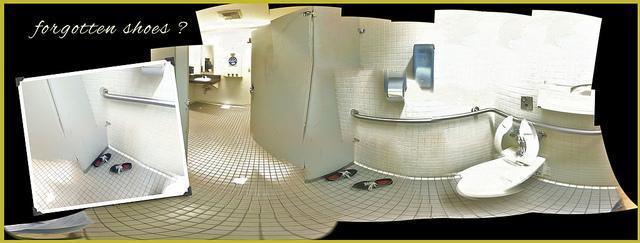How many shoes are in the picture?
Give a very brief answer. 2. 